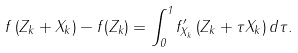Convert formula to latex. <formula><loc_0><loc_0><loc_500><loc_500>f \left ( Z _ { k } + X _ { k } \right ) - f ( Z _ { k } ) = \int _ { 0 } ^ { 1 } f _ { X _ { k } } ^ { \prime } \left ( Z _ { k } + \tau X _ { k } \right ) d \tau .</formula> 